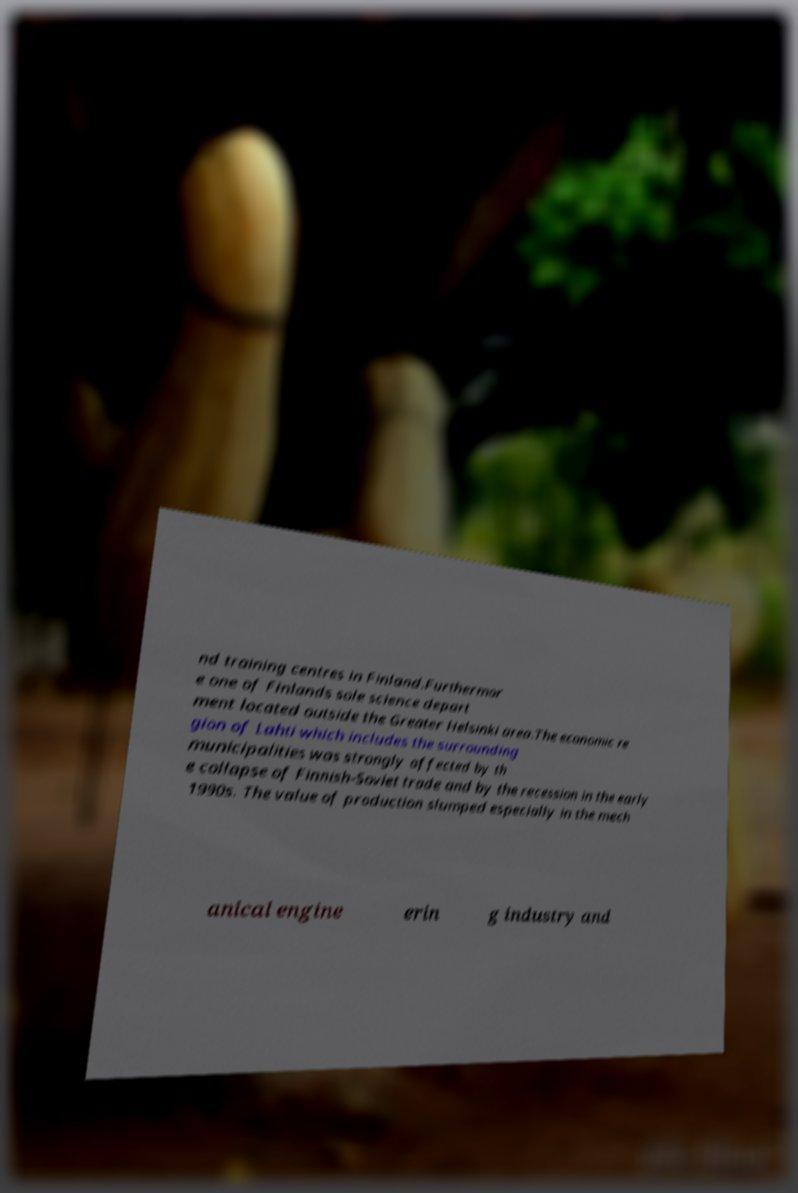Could you extract and type out the text from this image? nd training centres in Finland.Furthermor e one of Finlands sole science depart ment located outside the Greater Helsinki area.The economic re gion of Lahti which includes the surrounding municipalities was strongly affected by th e collapse of Finnish-Soviet trade and by the recession in the early 1990s. The value of production slumped especially in the mech anical engine erin g industry and 